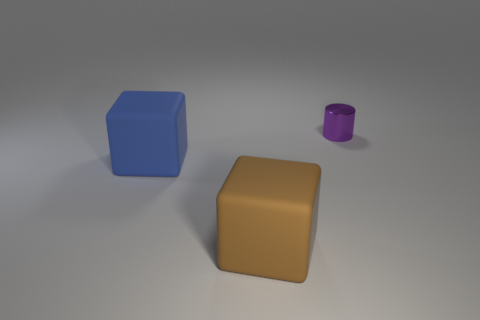The large object in front of the large matte thing on the left side of the object in front of the large blue object is what color? brown 